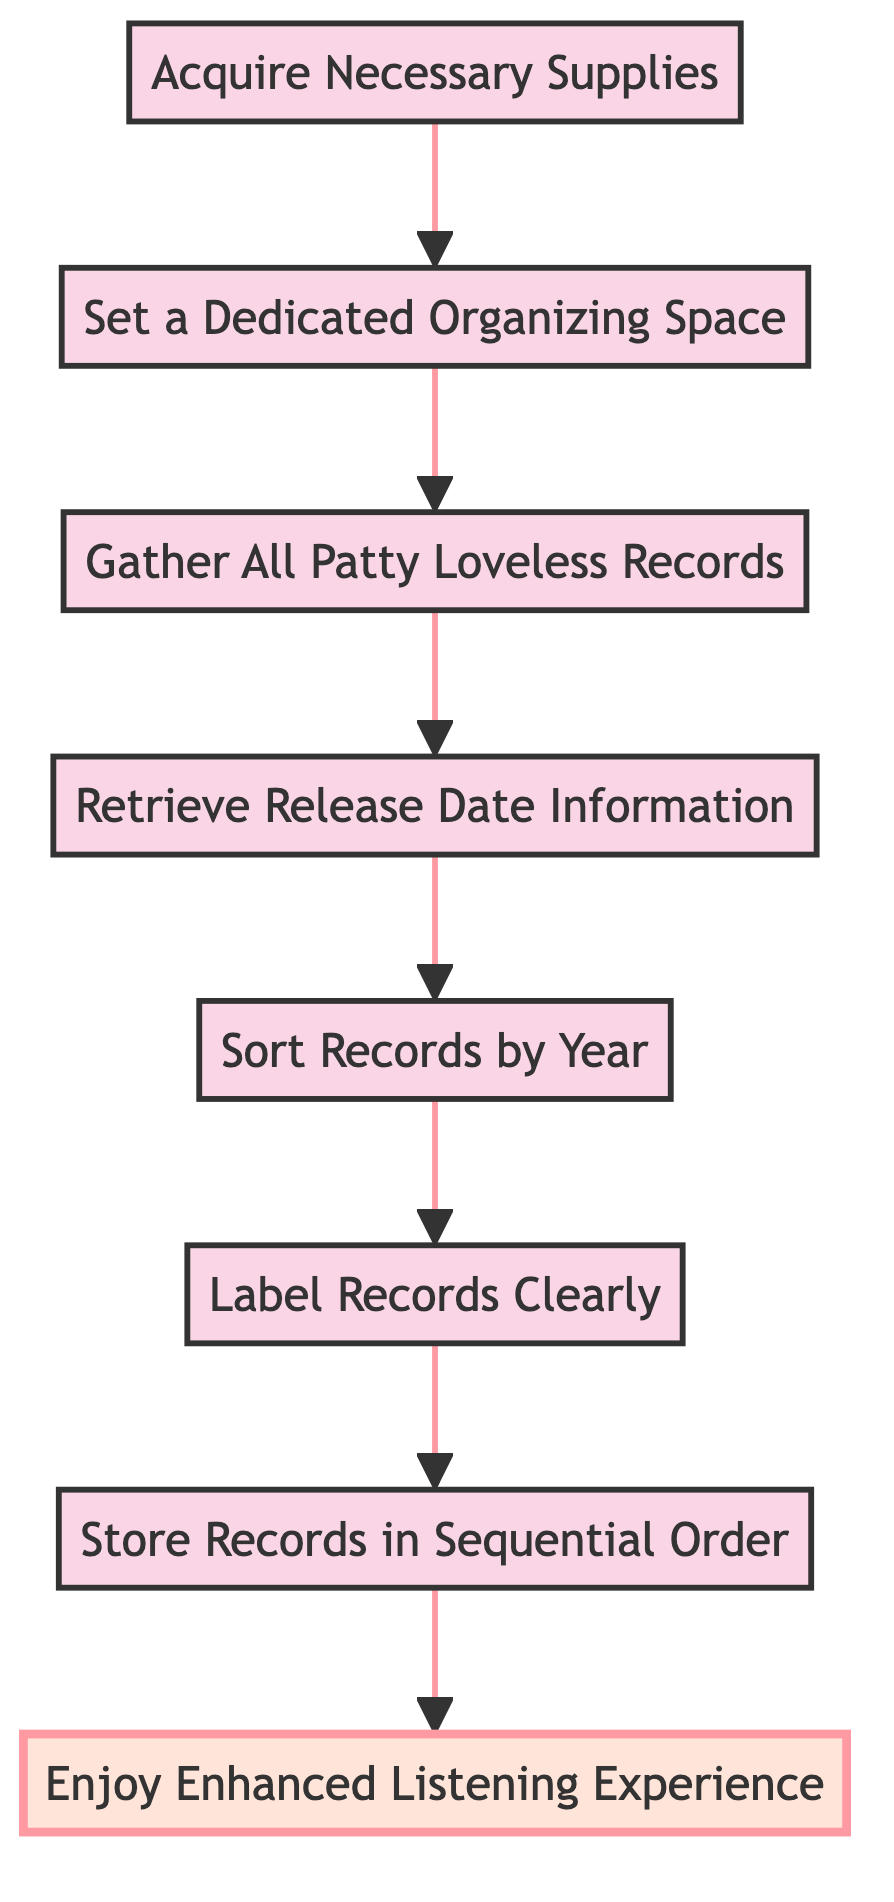What is the first step in the organization process? The first step is labeled as "Acquire Necessary Supplies," which indicates the starting point of the process. This node is at the bottom of the flowchart, showing it as the initial action before any other steps can be taken.
Answer: Acquire Necessary Supplies How many total steps are in the diagram? By counting the nodes in the flowchart, we can identify that there are eight distinct steps listed which represent the process to organize the vinyl collection.
Answer: 8 Which step comes directly after "Gather All Patty Loveless Records"? The diagram shows that after "Gather All Patty Loveless Records," the next step is "Retrieve Release Date Information." This is indicated by the arrow leading from the "Gather" node to the "Retrieve" node.
Answer: Retrieve Release Date Information What is the last step of the organization process? The final step is labeled as "Enjoy Enhanced Listening Experience," which is at the top of the flowchart, signifying the culmination of the organizing process.
Answer: Enjoy Enhanced Listening Experience Which steps require physical actions like sorting or labeling? The steps that involve physical actions are "Sort Records by Year" and "Label Records Clearly," which are located in the middle of the flowchart, indicating they are part of the active organization process.
Answer: Sort Records by Year, Label Records Clearly What is the relationship between "Retrieve Release Date Information" and "Sort Records by Year"? The relationship is that "Retrieve Release Date Information" is directly followed by "Sort Records by Year," meaning that sorting cannot happen until the release dates are confirmed. This sequential relationship shows that one step depends on the completion of the previous step.
Answer: Sequential dependency What do you need to do after sorting the records? After sorting the records, the next step is to "Label Records Clearly," which emphasizes the importance of labeling after organizing them by release date.
Answer: Label Records Clearly 